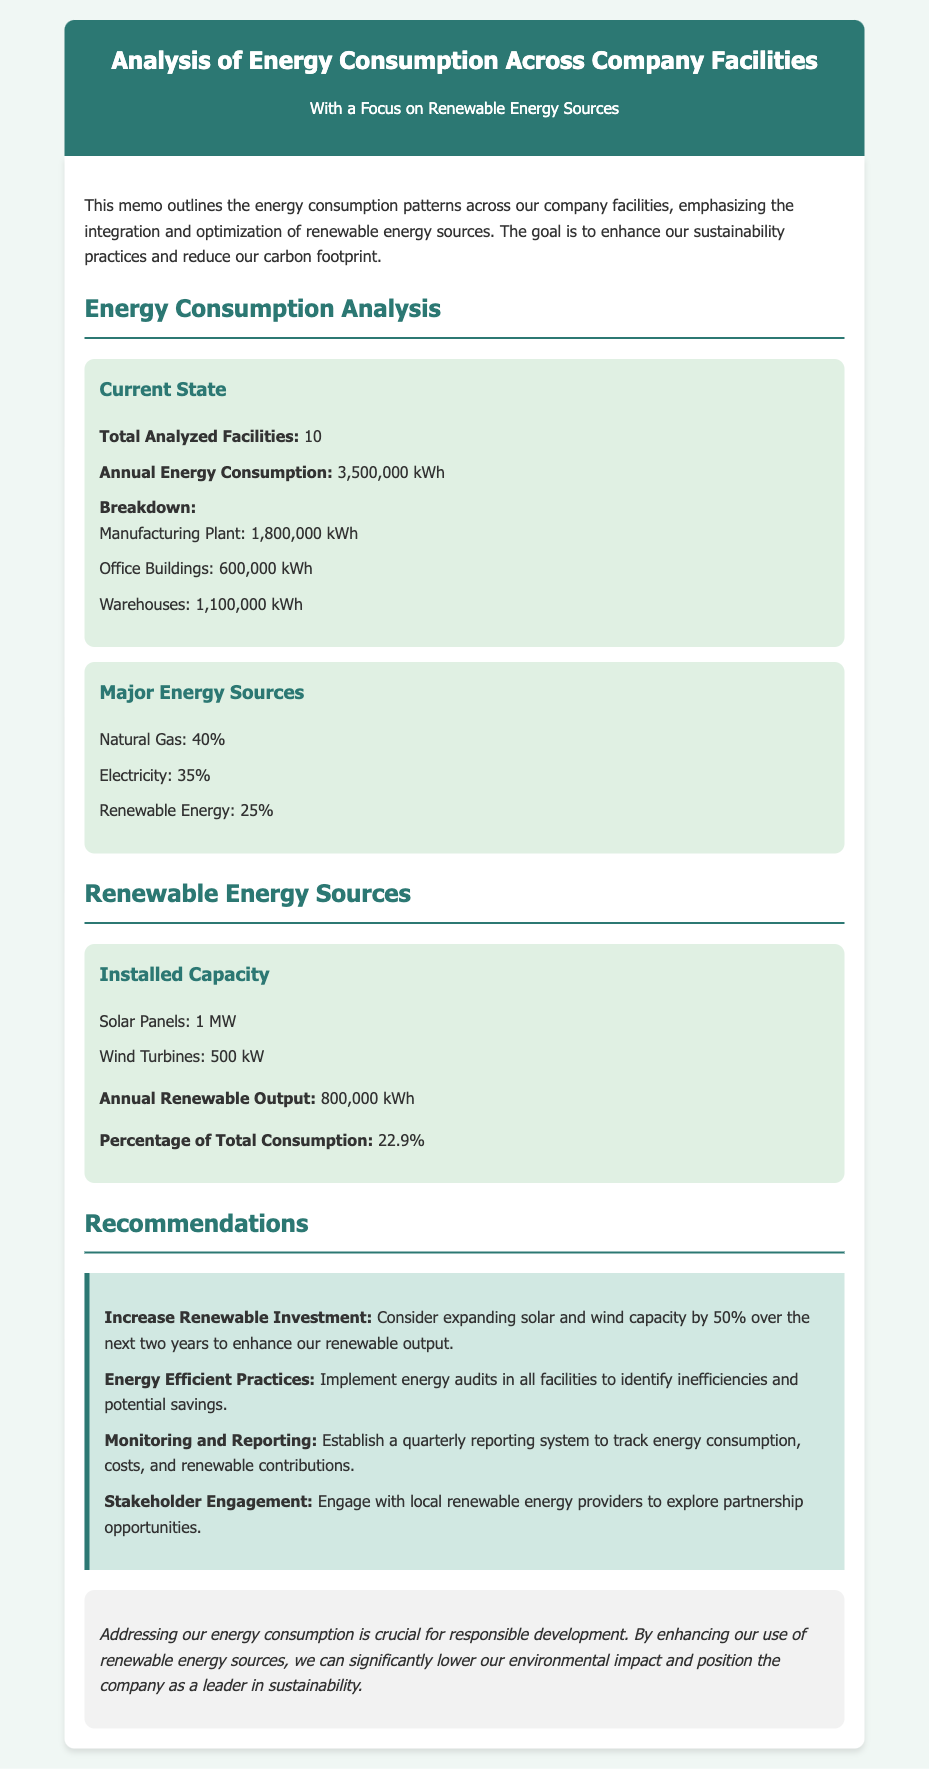What is the total number of analyzed facilities? The memo states the total number of analyzed facilities in the energy consumption analysis section.
Answer: 10 What is the annual energy consumption? The annual energy consumption is specifically mentioned in the document as part of the current state of energy consumption analysis.
Answer: 3,500,000 kWh What percentage of energy consumption comes from renewable sources? The percentage of total consumption from renewable energy is provided in the section on renewable energy sources.
Answer: 22.9% What is the installed capacity of solar panels? The installed capacity of solar panels is explicitly detailed in the renewable energy sources section of the memo.
Answer: 1 MW What is one recommendation for increasing renewable output? One of the recommendations given to enhance renewable output is mentioned in the recommendations section of the memo.
Answer: Increase Renewable Investment What is the major energy source with the highest percentage? The major energy source with the highest share is detailed in the major energy sources section of the memo.
Answer: Natural Gas What facility type consumes the most energy? The facility type with the highest annual energy consumption is highlighted in the breakdown of energy consumption.
Answer: Manufacturing Plant 